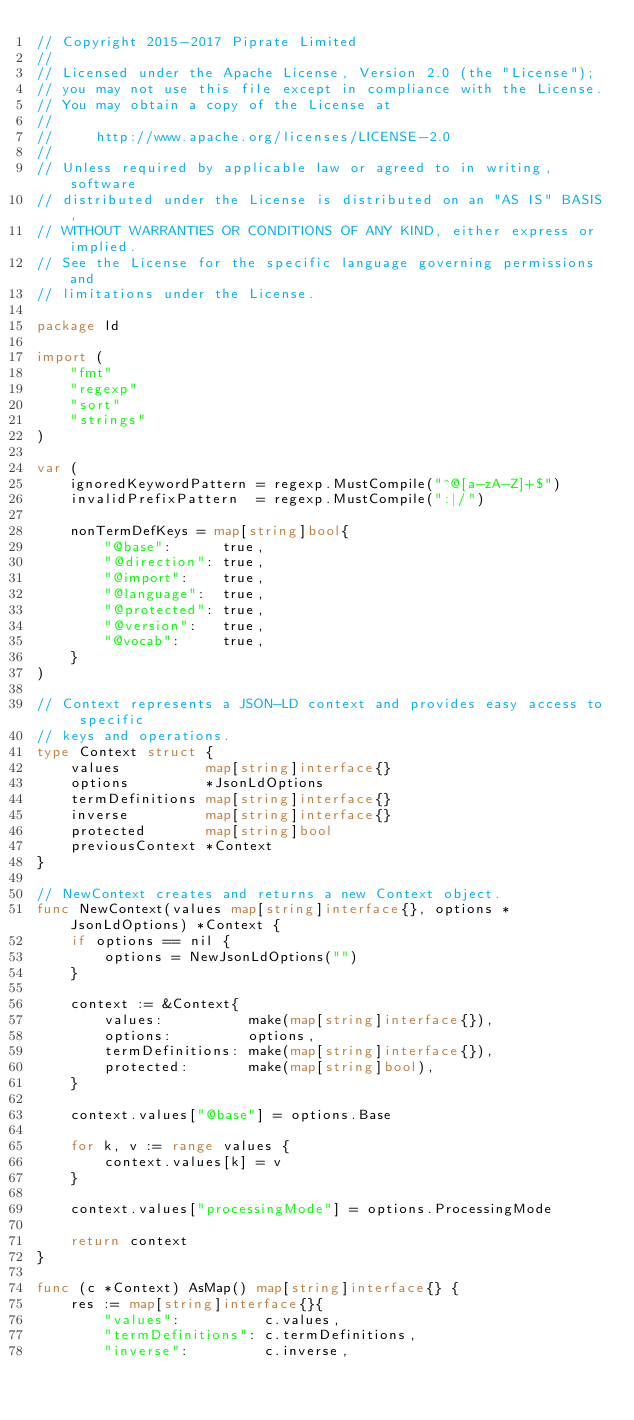<code> <loc_0><loc_0><loc_500><loc_500><_Go_>// Copyright 2015-2017 Piprate Limited
//
// Licensed under the Apache License, Version 2.0 (the "License");
// you may not use this file except in compliance with the License.
// You may obtain a copy of the License at
//
//     http://www.apache.org/licenses/LICENSE-2.0
//
// Unless required by applicable law or agreed to in writing, software
// distributed under the License is distributed on an "AS IS" BASIS,
// WITHOUT WARRANTIES OR CONDITIONS OF ANY KIND, either express or implied.
// See the License for the specific language governing permissions and
// limitations under the License.

package ld

import (
	"fmt"
	"regexp"
	"sort"
	"strings"
)

var (
	ignoredKeywordPattern = regexp.MustCompile("^@[a-zA-Z]+$")
	invalidPrefixPattern  = regexp.MustCompile(":|/")

	nonTermDefKeys = map[string]bool{
		"@base":      true,
		"@direction": true,
		"@import":    true,
		"@language":  true,
		"@protected": true,
		"@version":   true,
		"@vocab":     true,
	}
)

// Context represents a JSON-LD context and provides easy access to specific
// keys and operations.
type Context struct {
	values          map[string]interface{}
	options         *JsonLdOptions
	termDefinitions map[string]interface{}
	inverse         map[string]interface{}
	protected       map[string]bool
	previousContext *Context
}

// NewContext creates and returns a new Context object.
func NewContext(values map[string]interface{}, options *JsonLdOptions) *Context {
	if options == nil {
		options = NewJsonLdOptions("")
	}

	context := &Context{
		values:          make(map[string]interface{}),
		options:         options,
		termDefinitions: make(map[string]interface{}),
		protected:       make(map[string]bool),
	}

	context.values["@base"] = options.Base

	for k, v := range values {
		context.values[k] = v
	}

	context.values["processingMode"] = options.ProcessingMode

	return context
}

func (c *Context) AsMap() map[string]interface{} {
	res := map[string]interface{}{
		"values":          c.values,
		"termDefinitions": c.termDefinitions,
		"inverse":         c.inverse,</code> 